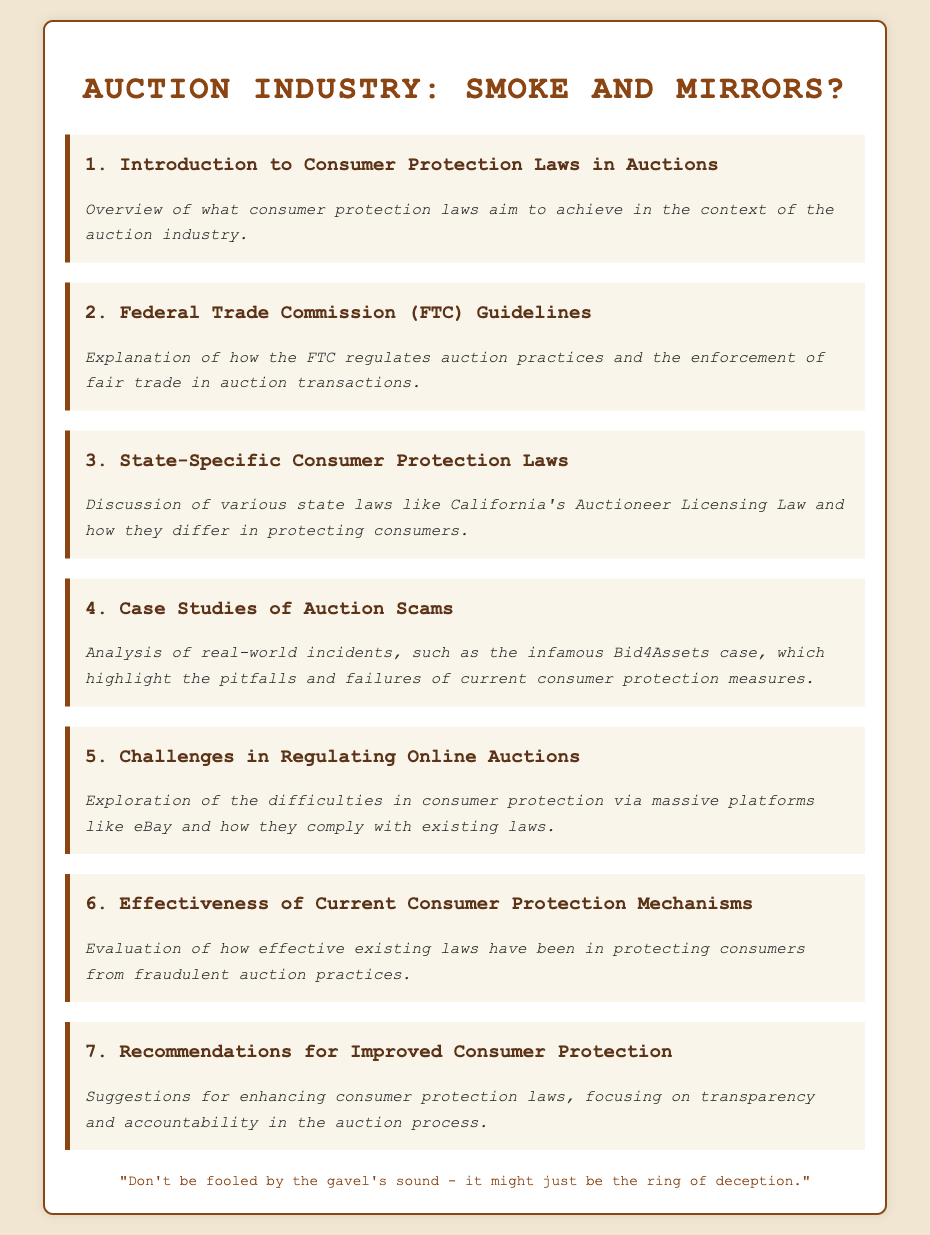What is the first agenda item? The first agenda item is listed as "Introduction to Consumer Protection Laws in Auctions."
Answer: Introduction to Consumer Protection Laws in Auctions What organization regulates auction practices at the federal level? The document mentions the Federal Trade Commission as the regulating body.
Answer: Federal Trade Commission (FTC) Which state's auction laws are specifically mentioned? California's Auctioneer Licensing Law is referenced in the document.
Answer: California What incident is highlighted as a case study of auction scams? The infamous Bid4Assets case is specifically mentioned as an example.
Answer: Bid4Assets What is a major challenge in regulating online auctions according to the agenda? The difficulties in consumer protection via massive platforms like eBay are discussed.
Answer: Difficulties in consumer protection via massive platforms like eBay What is the focus of the last agenda item? The last agenda item suggests enhancements to laws regarding transparency and accountability.
Answer: Transparency and accountability in the auction process How many agenda items are listed in total? The document outlines seven agenda items.
Answer: Seven What is the tone of the closing quote? The closing quote implies skepticism about the auction industry's legitimacy.
Answer: Skepticism 